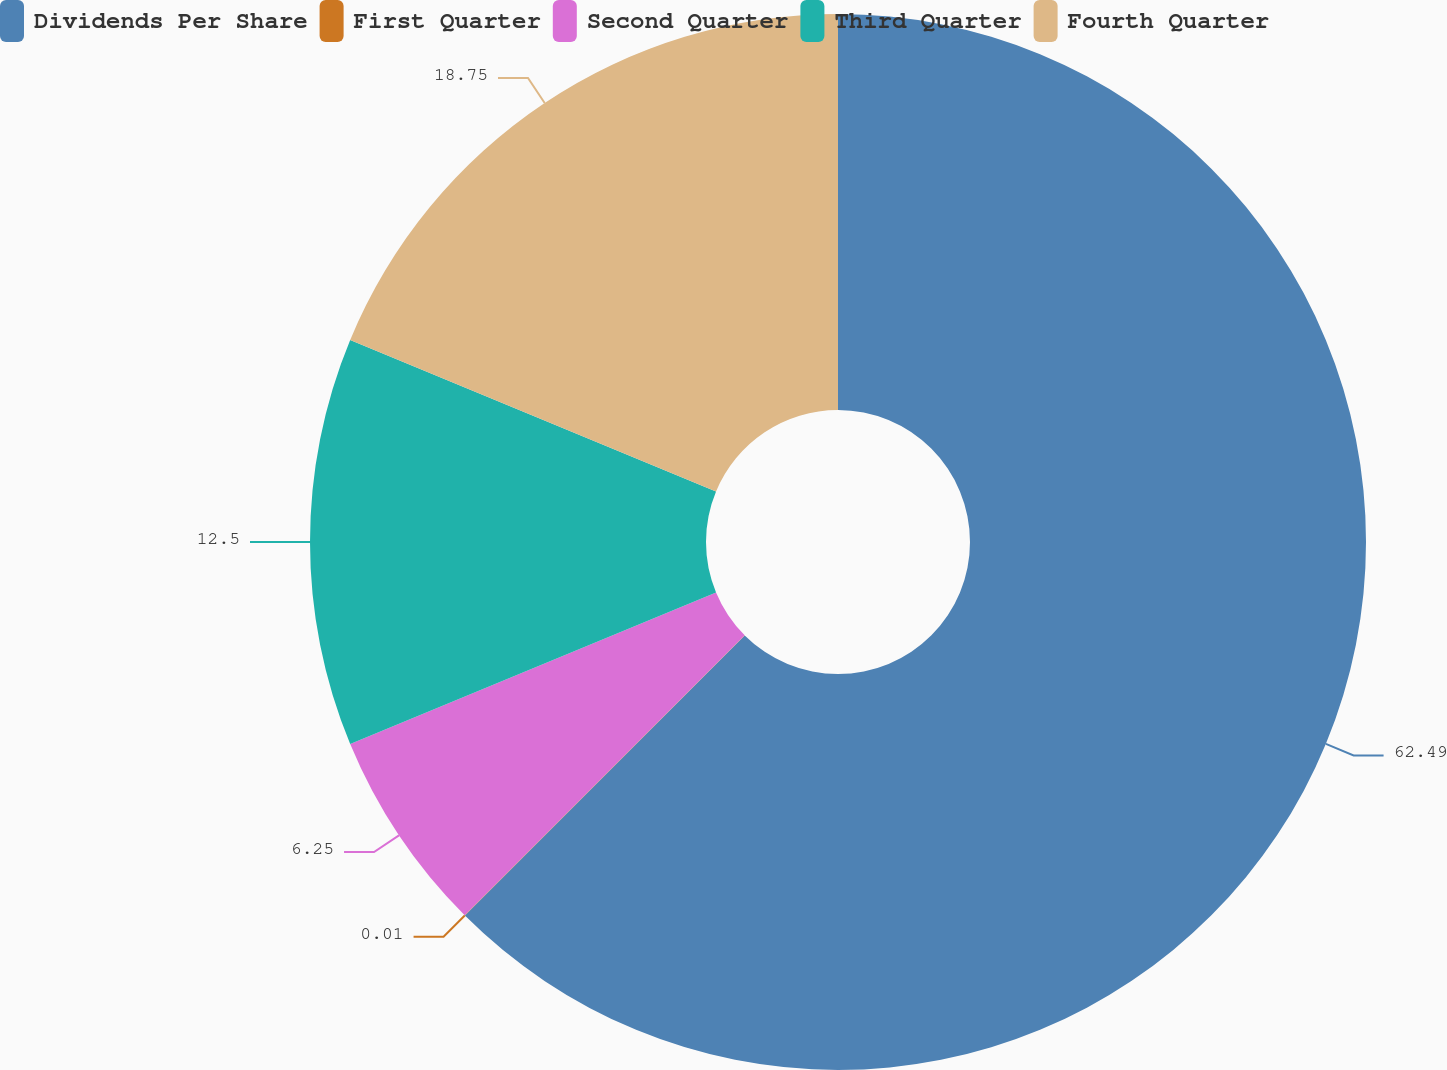Convert chart to OTSL. <chart><loc_0><loc_0><loc_500><loc_500><pie_chart><fcel>Dividends Per Share<fcel>First Quarter<fcel>Second Quarter<fcel>Third Quarter<fcel>Fourth Quarter<nl><fcel>62.49%<fcel>0.01%<fcel>6.25%<fcel>12.5%<fcel>18.75%<nl></chart> 